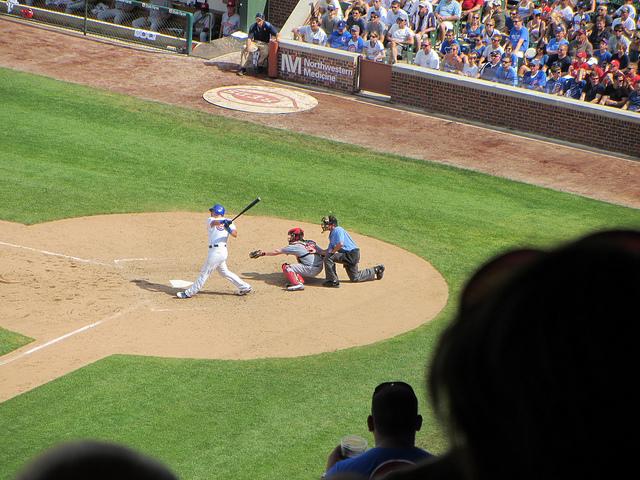Has the player struck the ball yet?
Be succinct. Yes. What color is the batter's helmet?
Short answer required. Blue. Is the hitter prepared to strike a fast pitch?
Write a very short answer. Yes. 